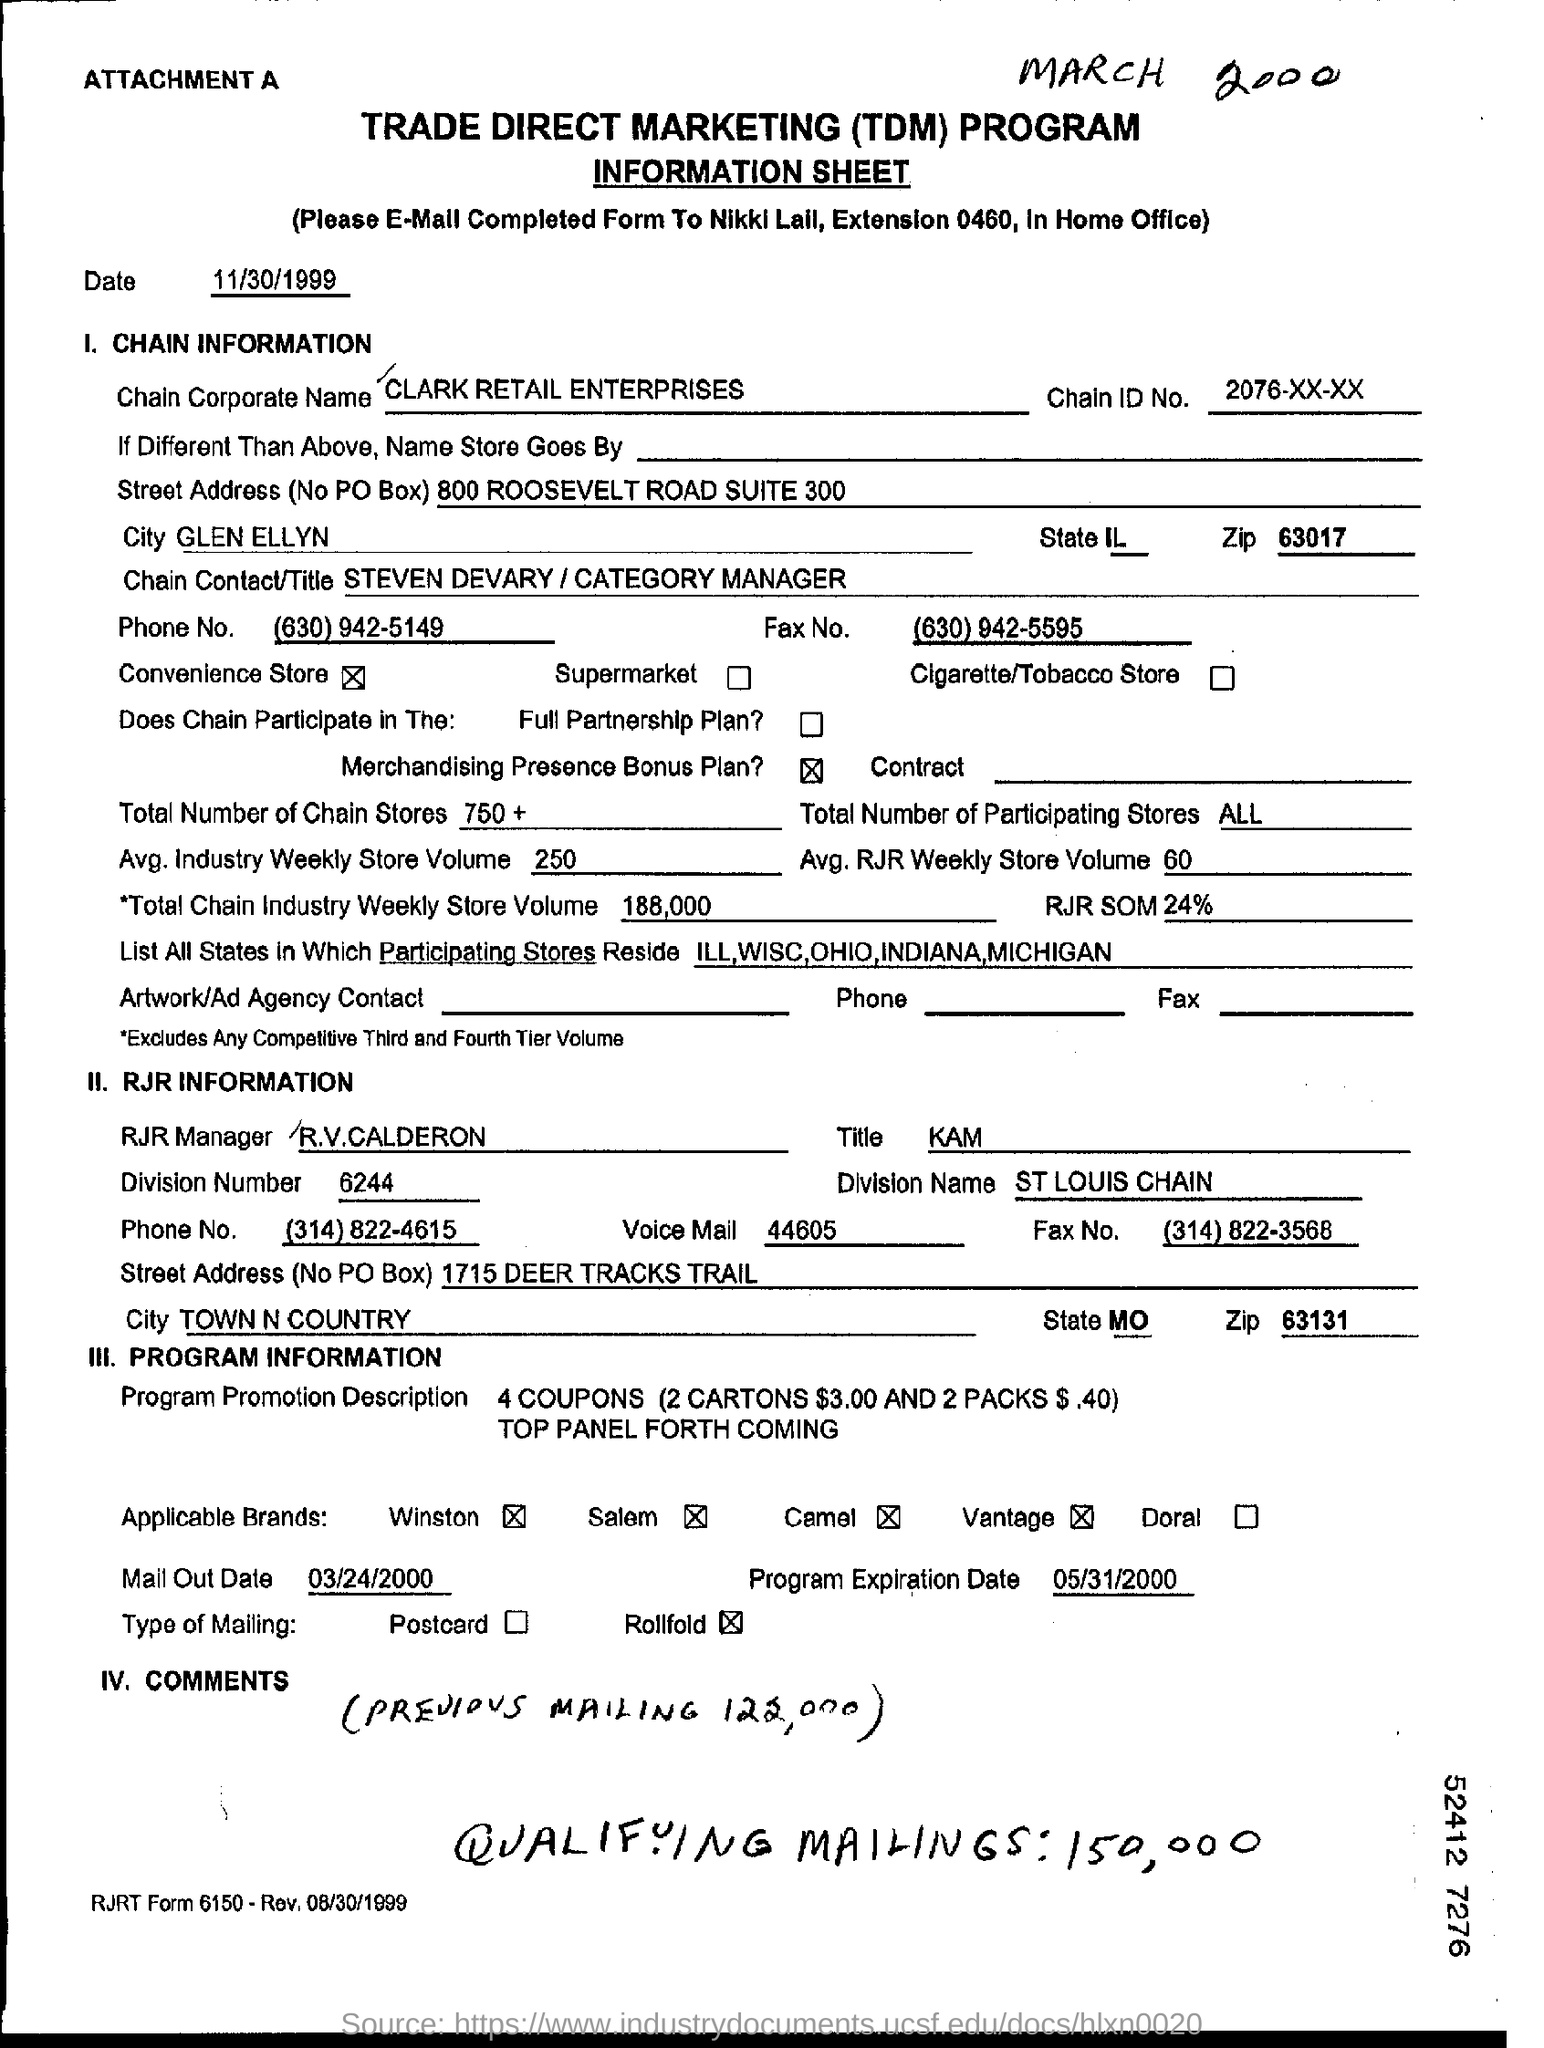Mention a couple of crucial points in this snapshot. The Chain ID No is a unique identifier assigned to a particular chain, consisting of three sets of numbers separated by hyphens, for example 2076-xx-xx. Clark Retail Enterprises, also known as Chain Corporate Name, is a company that specializes in various retail services and operations. The average weekly store volume for the industry is approximately 250. 